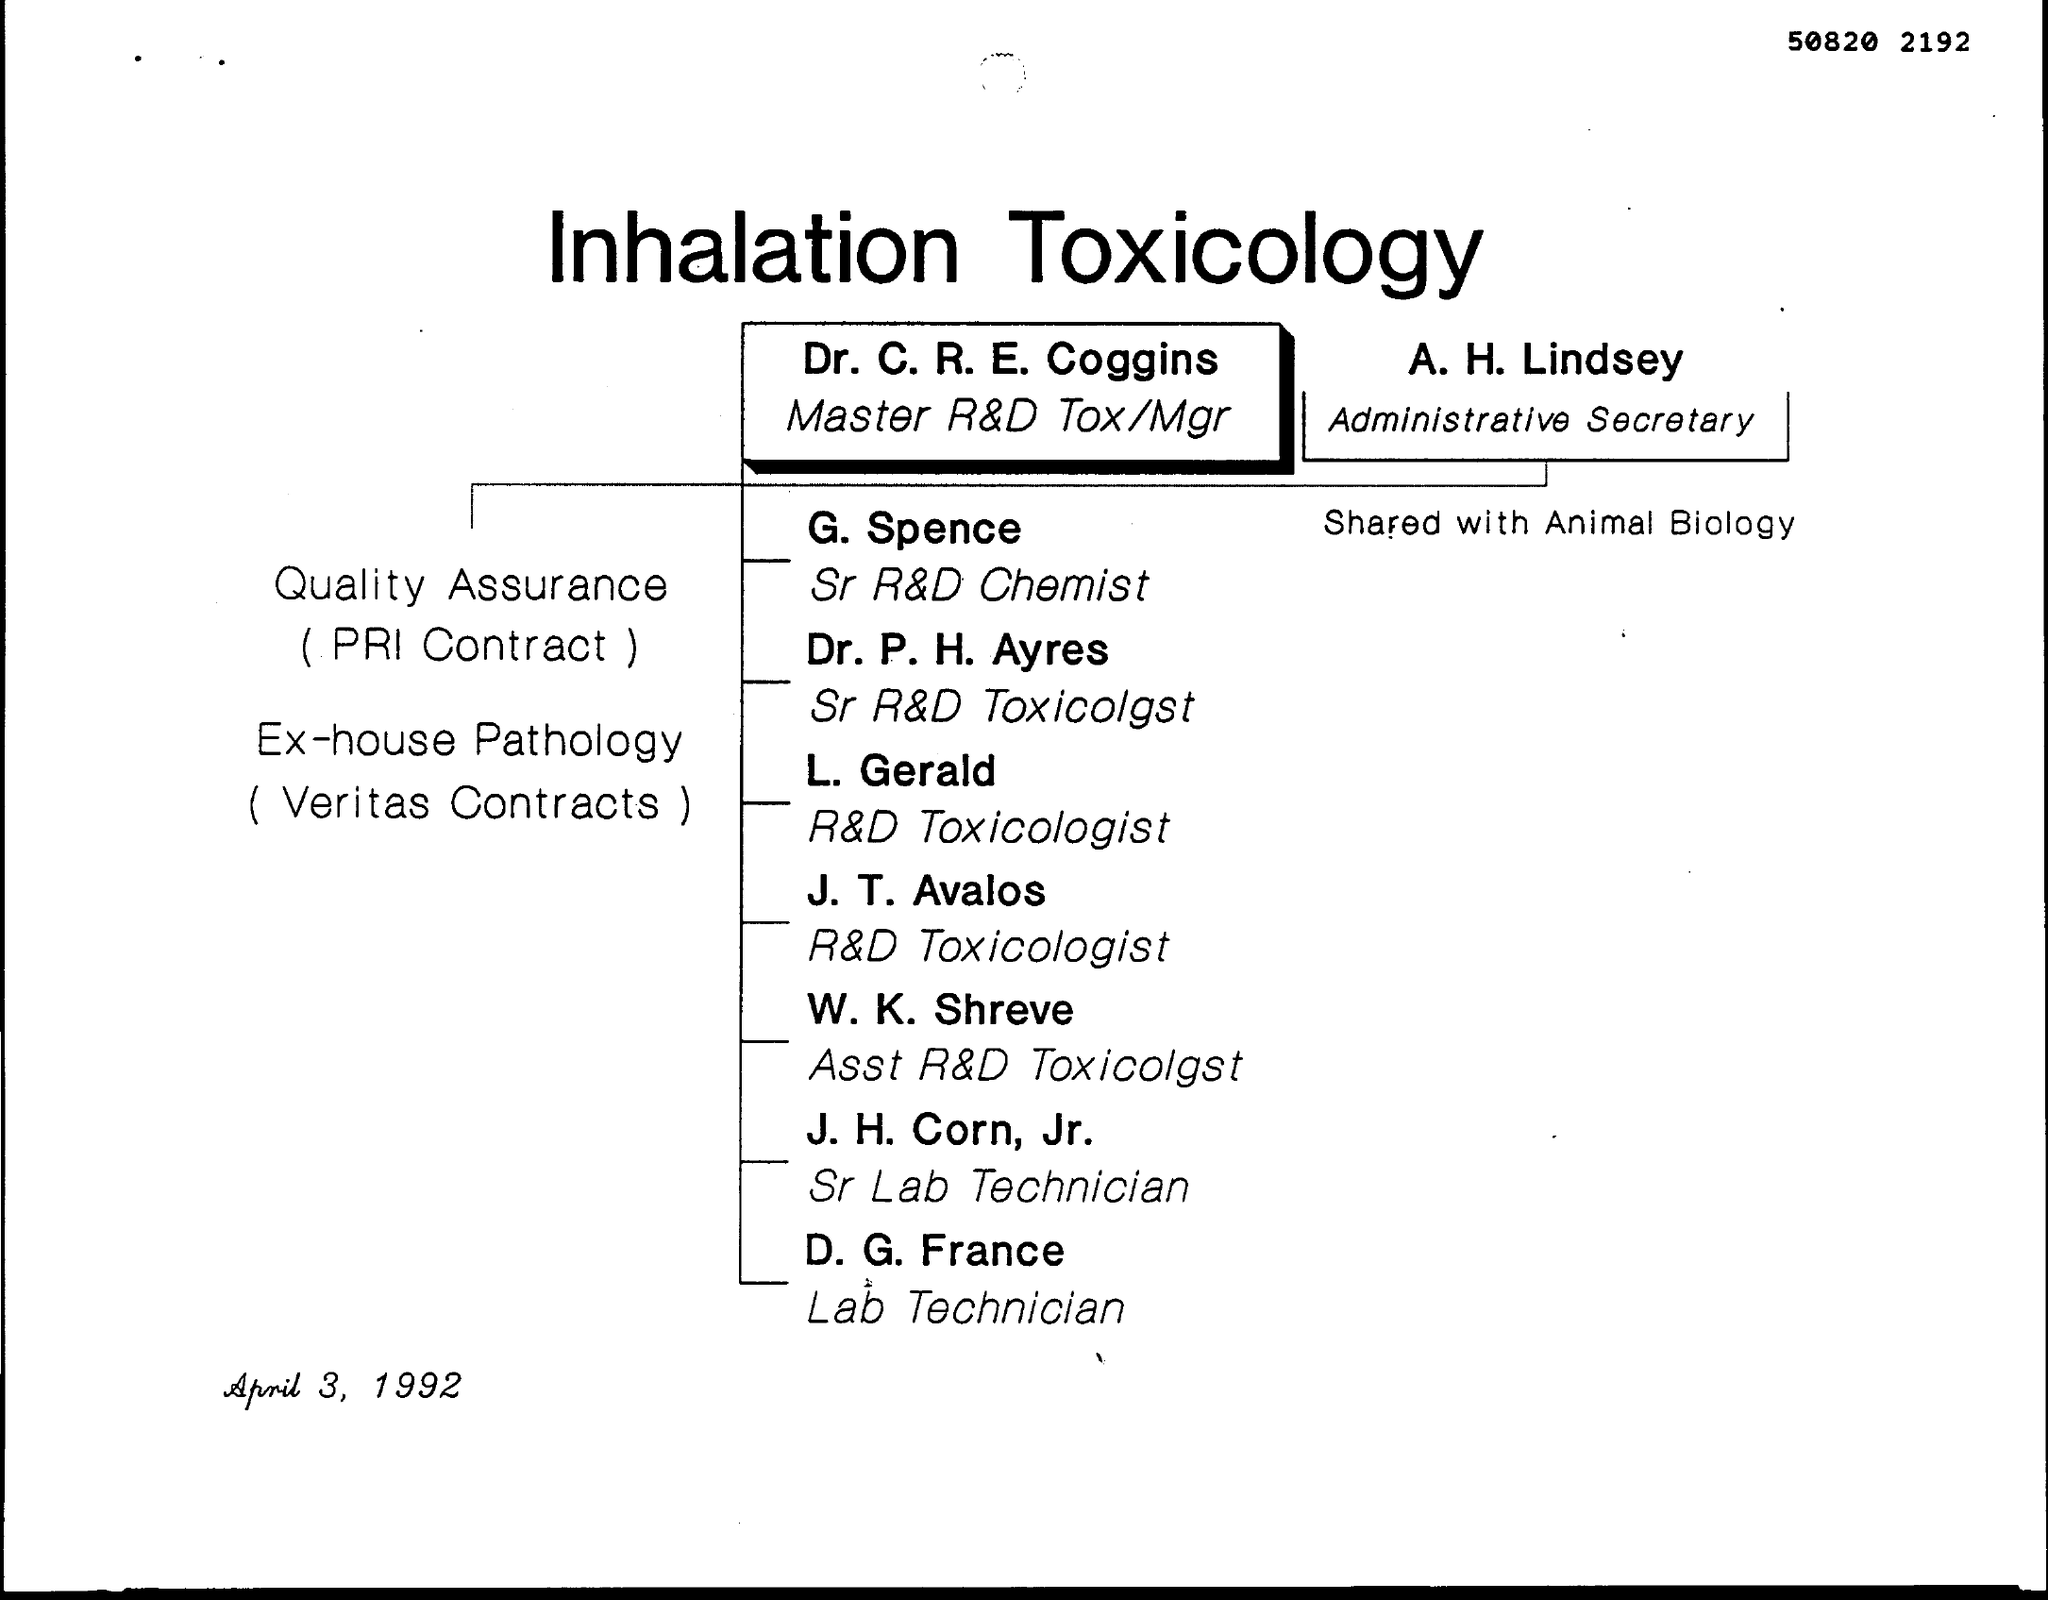Indicate a few pertinent items in this graphic. The title of this document is Inhalation Toxicology. H. Lindsey is the Administrative Secretary. Dr. C. R. E. Coggins holds the designation of Master R&D Tox/Mgr. The number written at the top of the page is 50820, followed by 2192. The document was dated April 3, 1992. 